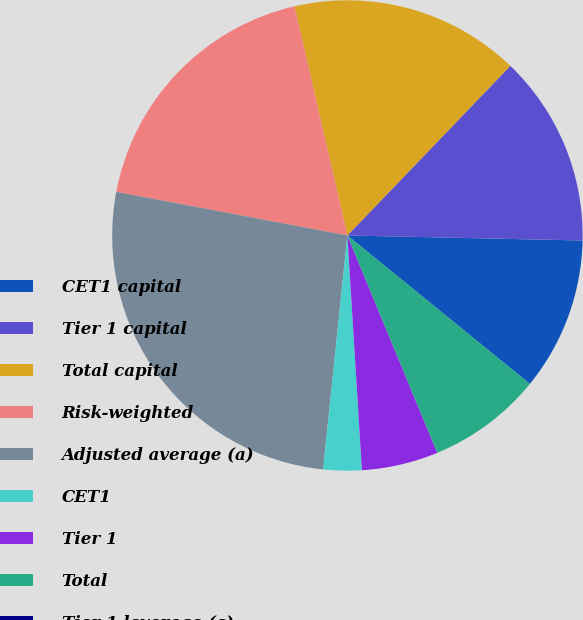Convert chart. <chart><loc_0><loc_0><loc_500><loc_500><pie_chart><fcel>CET1 capital<fcel>Tier 1 capital<fcel>Total capital<fcel>Risk-weighted<fcel>Adjusted average (a)<fcel>CET1<fcel>Tier 1<fcel>Total<fcel>Tier 1 leverage (c)<nl><fcel>10.53%<fcel>13.16%<fcel>15.79%<fcel>18.42%<fcel>26.32%<fcel>2.63%<fcel>5.26%<fcel>7.89%<fcel>0.0%<nl></chart> 